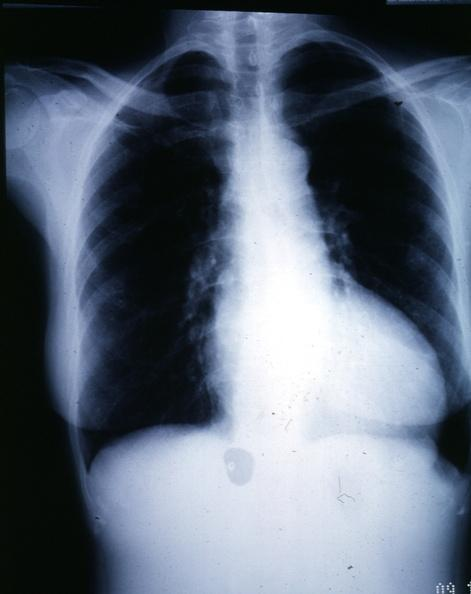does this image show x-ray epa chest with obvious cardiomegaly female with aortic valve stenosis?
Answer the question using a single word or phrase. Yes 